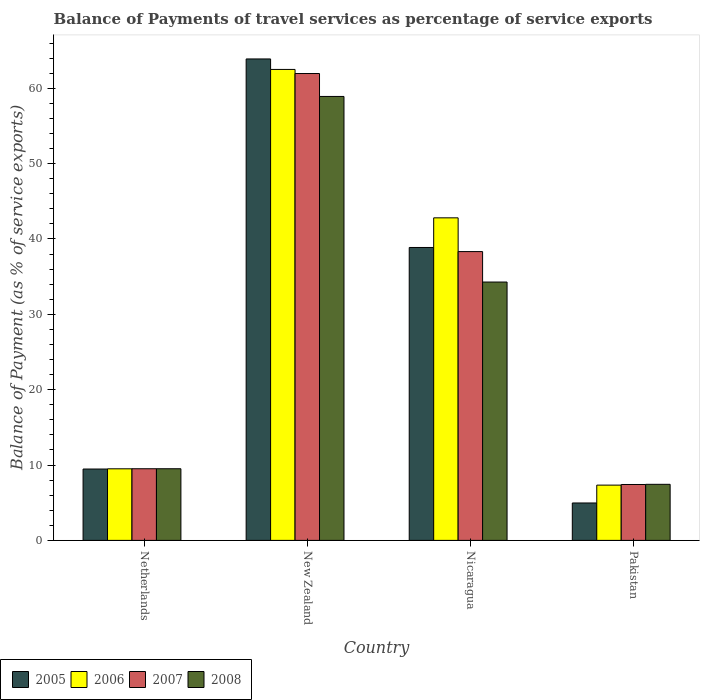How many groups of bars are there?
Your answer should be very brief. 4. What is the label of the 2nd group of bars from the left?
Offer a very short reply. New Zealand. What is the balance of payments of travel services in 2006 in New Zealand?
Your answer should be very brief. 62.5. Across all countries, what is the maximum balance of payments of travel services in 2008?
Your response must be concise. 58.91. Across all countries, what is the minimum balance of payments of travel services in 2005?
Your answer should be compact. 4.97. In which country was the balance of payments of travel services in 2006 maximum?
Your response must be concise. New Zealand. What is the total balance of payments of travel services in 2006 in the graph?
Your answer should be very brief. 122.14. What is the difference between the balance of payments of travel services in 2005 in New Zealand and that in Pakistan?
Provide a short and direct response. 58.93. What is the difference between the balance of payments of travel services in 2006 in Netherlands and the balance of payments of travel services in 2007 in Nicaragua?
Make the answer very short. -28.83. What is the average balance of payments of travel services in 2006 per country?
Keep it short and to the point. 30.54. What is the difference between the balance of payments of travel services of/in 2006 and balance of payments of travel services of/in 2008 in New Zealand?
Make the answer very short. 3.59. What is the ratio of the balance of payments of travel services in 2008 in Nicaragua to that in Pakistan?
Offer a very short reply. 4.61. What is the difference between the highest and the second highest balance of payments of travel services in 2008?
Offer a terse response. -49.41. What is the difference between the highest and the lowest balance of payments of travel services in 2007?
Keep it short and to the point. 54.54. What does the 4th bar from the right in New Zealand represents?
Your response must be concise. 2005. How many countries are there in the graph?
Provide a succinct answer. 4. Does the graph contain any zero values?
Make the answer very short. No. Does the graph contain grids?
Provide a short and direct response. No. How many legend labels are there?
Make the answer very short. 4. What is the title of the graph?
Your answer should be compact. Balance of Payments of travel services as percentage of service exports. Does "1983" appear as one of the legend labels in the graph?
Make the answer very short. No. What is the label or title of the X-axis?
Your response must be concise. Country. What is the label or title of the Y-axis?
Offer a very short reply. Balance of Payment (as % of service exports). What is the Balance of Payment (as % of service exports) in 2005 in Netherlands?
Your response must be concise. 9.47. What is the Balance of Payment (as % of service exports) in 2006 in Netherlands?
Offer a terse response. 9.5. What is the Balance of Payment (as % of service exports) in 2007 in Netherlands?
Offer a very short reply. 9.51. What is the Balance of Payment (as % of service exports) of 2008 in Netherlands?
Your answer should be compact. 9.51. What is the Balance of Payment (as % of service exports) in 2005 in New Zealand?
Make the answer very short. 63.89. What is the Balance of Payment (as % of service exports) of 2006 in New Zealand?
Make the answer very short. 62.5. What is the Balance of Payment (as % of service exports) in 2007 in New Zealand?
Offer a terse response. 61.96. What is the Balance of Payment (as % of service exports) in 2008 in New Zealand?
Offer a very short reply. 58.91. What is the Balance of Payment (as % of service exports) of 2005 in Nicaragua?
Offer a terse response. 38.87. What is the Balance of Payment (as % of service exports) in 2006 in Nicaragua?
Provide a succinct answer. 42.81. What is the Balance of Payment (as % of service exports) in 2007 in Nicaragua?
Your answer should be compact. 38.33. What is the Balance of Payment (as % of service exports) of 2008 in Nicaragua?
Your response must be concise. 34.29. What is the Balance of Payment (as % of service exports) in 2005 in Pakistan?
Offer a very short reply. 4.97. What is the Balance of Payment (as % of service exports) of 2006 in Pakistan?
Ensure brevity in your answer.  7.34. What is the Balance of Payment (as % of service exports) of 2007 in Pakistan?
Offer a very short reply. 7.42. What is the Balance of Payment (as % of service exports) of 2008 in Pakistan?
Keep it short and to the point. 7.44. Across all countries, what is the maximum Balance of Payment (as % of service exports) of 2005?
Ensure brevity in your answer.  63.89. Across all countries, what is the maximum Balance of Payment (as % of service exports) of 2006?
Offer a terse response. 62.5. Across all countries, what is the maximum Balance of Payment (as % of service exports) of 2007?
Your answer should be compact. 61.96. Across all countries, what is the maximum Balance of Payment (as % of service exports) of 2008?
Your response must be concise. 58.91. Across all countries, what is the minimum Balance of Payment (as % of service exports) in 2005?
Your answer should be compact. 4.97. Across all countries, what is the minimum Balance of Payment (as % of service exports) of 2006?
Offer a very short reply. 7.34. Across all countries, what is the minimum Balance of Payment (as % of service exports) in 2007?
Provide a short and direct response. 7.42. Across all countries, what is the minimum Balance of Payment (as % of service exports) in 2008?
Keep it short and to the point. 7.44. What is the total Balance of Payment (as % of service exports) of 2005 in the graph?
Your answer should be very brief. 117.2. What is the total Balance of Payment (as % of service exports) in 2006 in the graph?
Offer a very short reply. 122.14. What is the total Balance of Payment (as % of service exports) in 2007 in the graph?
Offer a very short reply. 117.21. What is the total Balance of Payment (as % of service exports) in 2008 in the graph?
Offer a terse response. 110.15. What is the difference between the Balance of Payment (as % of service exports) in 2005 in Netherlands and that in New Zealand?
Make the answer very short. -54.42. What is the difference between the Balance of Payment (as % of service exports) in 2006 in Netherlands and that in New Zealand?
Your answer should be very brief. -53. What is the difference between the Balance of Payment (as % of service exports) of 2007 in Netherlands and that in New Zealand?
Give a very brief answer. -52.45. What is the difference between the Balance of Payment (as % of service exports) of 2008 in Netherlands and that in New Zealand?
Provide a succinct answer. -49.41. What is the difference between the Balance of Payment (as % of service exports) of 2005 in Netherlands and that in Nicaragua?
Your answer should be very brief. -29.4. What is the difference between the Balance of Payment (as % of service exports) in 2006 in Netherlands and that in Nicaragua?
Ensure brevity in your answer.  -33.31. What is the difference between the Balance of Payment (as % of service exports) of 2007 in Netherlands and that in Nicaragua?
Keep it short and to the point. -28.82. What is the difference between the Balance of Payment (as % of service exports) in 2008 in Netherlands and that in Nicaragua?
Your answer should be compact. -24.78. What is the difference between the Balance of Payment (as % of service exports) in 2005 in Netherlands and that in Pakistan?
Offer a very short reply. 4.51. What is the difference between the Balance of Payment (as % of service exports) of 2006 in Netherlands and that in Pakistan?
Your answer should be very brief. 2.16. What is the difference between the Balance of Payment (as % of service exports) in 2007 in Netherlands and that in Pakistan?
Make the answer very short. 2.09. What is the difference between the Balance of Payment (as % of service exports) in 2008 in Netherlands and that in Pakistan?
Your answer should be compact. 2.07. What is the difference between the Balance of Payment (as % of service exports) of 2005 in New Zealand and that in Nicaragua?
Your response must be concise. 25.02. What is the difference between the Balance of Payment (as % of service exports) of 2006 in New Zealand and that in Nicaragua?
Give a very brief answer. 19.69. What is the difference between the Balance of Payment (as % of service exports) in 2007 in New Zealand and that in Nicaragua?
Provide a succinct answer. 23.63. What is the difference between the Balance of Payment (as % of service exports) of 2008 in New Zealand and that in Nicaragua?
Your answer should be compact. 24.63. What is the difference between the Balance of Payment (as % of service exports) of 2005 in New Zealand and that in Pakistan?
Your response must be concise. 58.93. What is the difference between the Balance of Payment (as % of service exports) of 2006 in New Zealand and that in Pakistan?
Your answer should be very brief. 55.17. What is the difference between the Balance of Payment (as % of service exports) of 2007 in New Zealand and that in Pakistan?
Provide a succinct answer. 54.54. What is the difference between the Balance of Payment (as % of service exports) in 2008 in New Zealand and that in Pakistan?
Provide a short and direct response. 51.47. What is the difference between the Balance of Payment (as % of service exports) of 2005 in Nicaragua and that in Pakistan?
Your answer should be compact. 33.91. What is the difference between the Balance of Payment (as % of service exports) of 2006 in Nicaragua and that in Pakistan?
Your answer should be compact. 35.47. What is the difference between the Balance of Payment (as % of service exports) in 2007 in Nicaragua and that in Pakistan?
Offer a very short reply. 30.91. What is the difference between the Balance of Payment (as % of service exports) in 2008 in Nicaragua and that in Pakistan?
Your answer should be very brief. 26.85. What is the difference between the Balance of Payment (as % of service exports) of 2005 in Netherlands and the Balance of Payment (as % of service exports) of 2006 in New Zealand?
Offer a very short reply. -53.03. What is the difference between the Balance of Payment (as % of service exports) in 2005 in Netherlands and the Balance of Payment (as % of service exports) in 2007 in New Zealand?
Make the answer very short. -52.49. What is the difference between the Balance of Payment (as % of service exports) in 2005 in Netherlands and the Balance of Payment (as % of service exports) in 2008 in New Zealand?
Keep it short and to the point. -49.44. What is the difference between the Balance of Payment (as % of service exports) of 2006 in Netherlands and the Balance of Payment (as % of service exports) of 2007 in New Zealand?
Offer a very short reply. -52.46. What is the difference between the Balance of Payment (as % of service exports) of 2006 in Netherlands and the Balance of Payment (as % of service exports) of 2008 in New Zealand?
Offer a very short reply. -49.42. What is the difference between the Balance of Payment (as % of service exports) in 2007 in Netherlands and the Balance of Payment (as % of service exports) in 2008 in New Zealand?
Your answer should be very brief. -49.41. What is the difference between the Balance of Payment (as % of service exports) of 2005 in Netherlands and the Balance of Payment (as % of service exports) of 2006 in Nicaragua?
Offer a very short reply. -33.34. What is the difference between the Balance of Payment (as % of service exports) of 2005 in Netherlands and the Balance of Payment (as % of service exports) of 2007 in Nicaragua?
Offer a very short reply. -28.85. What is the difference between the Balance of Payment (as % of service exports) in 2005 in Netherlands and the Balance of Payment (as % of service exports) in 2008 in Nicaragua?
Provide a succinct answer. -24.81. What is the difference between the Balance of Payment (as % of service exports) in 2006 in Netherlands and the Balance of Payment (as % of service exports) in 2007 in Nicaragua?
Your response must be concise. -28.83. What is the difference between the Balance of Payment (as % of service exports) of 2006 in Netherlands and the Balance of Payment (as % of service exports) of 2008 in Nicaragua?
Keep it short and to the point. -24.79. What is the difference between the Balance of Payment (as % of service exports) of 2007 in Netherlands and the Balance of Payment (as % of service exports) of 2008 in Nicaragua?
Offer a terse response. -24.78. What is the difference between the Balance of Payment (as % of service exports) in 2005 in Netherlands and the Balance of Payment (as % of service exports) in 2006 in Pakistan?
Offer a terse response. 2.14. What is the difference between the Balance of Payment (as % of service exports) of 2005 in Netherlands and the Balance of Payment (as % of service exports) of 2007 in Pakistan?
Make the answer very short. 2.05. What is the difference between the Balance of Payment (as % of service exports) of 2005 in Netherlands and the Balance of Payment (as % of service exports) of 2008 in Pakistan?
Ensure brevity in your answer.  2.03. What is the difference between the Balance of Payment (as % of service exports) of 2006 in Netherlands and the Balance of Payment (as % of service exports) of 2007 in Pakistan?
Your answer should be compact. 2.08. What is the difference between the Balance of Payment (as % of service exports) in 2006 in Netherlands and the Balance of Payment (as % of service exports) in 2008 in Pakistan?
Your answer should be very brief. 2.06. What is the difference between the Balance of Payment (as % of service exports) of 2007 in Netherlands and the Balance of Payment (as % of service exports) of 2008 in Pakistan?
Your response must be concise. 2.07. What is the difference between the Balance of Payment (as % of service exports) in 2005 in New Zealand and the Balance of Payment (as % of service exports) in 2006 in Nicaragua?
Offer a very short reply. 21.09. What is the difference between the Balance of Payment (as % of service exports) of 2005 in New Zealand and the Balance of Payment (as % of service exports) of 2007 in Nicaragua?
Offer a terse response. 25.57. What is the difference between the Balance of Payment (as % of service exports) of 2005 in New Zealand and the Balance of Payment (as % of service exports) of 2008 in Nicaragua?
Offer a very short reply. 29.61. What is the difference between the Balance of Payment (as % of service exports) in 2006 in New Zealand and the Balance of Payment (as % of service exports) in 2007 in Nicaragua?
Keep it short and to the point. 24.18. What is the difference between the Balance of Payment (as % of service exports) in 2006 in New Zealand and the Balance of Payment (as % of service exports) in 2008 in Nicaragua?
Your answer should be compact. 28.21. What is the difference between the Balance of Payment (as % of service exports) in 2007 in New Zealand and the Balance of Payment (as % of service exports) in 2008 in Nicaragua?
Provide a succinct answer. 27.67. What is the difference between the Balance of Payment (as % of service exports) of 2005 in New Zealand and the Balance of Payment (as % of service exports) of 2006 in Pakistan?
Keep it short and to the point. 56.56. What is the difference between the Balance of Payment (as % of service exports) in 2005 in New Zealand and the Balance of Payment (as % of service exports) in 2007 in Pakistan?
Make the answer very short. 56.47. What is the difference between the Balance of Payment (as % of service exports) of 2005 in New Zealand and the Balance of Payment (as % of service exports) of 2008 in Pakistan?
Provide a short and direct response. 56.45. What is the difference between the Balance of Payment (as % of service exports) in 2006 in New Zealand and the Balance of Payment (as % of service exports) in 2007 in Pakistan?
Ensure brevity in your answer.  55.08. What is the difference between the Balance of Payment (as % of service exports) of 2006 in New Zealand and the Balance of Payment (as % of service exports) of 2008 in Pakistan?
Your response must be concise. 55.06. What is the difference between the Balance of Payment (as % of service exports) in 2007 in New Zealand and the Balance of Payment (as % of service exports) in 2008 in Pakistan?
Make the answer very short. 54.52. What is the difference between the Balance of Payment (as % of service exports) in 2005 in Nicaragua and the Balance of Payment (as % of service exports) in 2006 in Pakistan?
Make the answer very short. 31.54. What is the difference between the Balance of Payment (as % of service exports) of 2005 in Nicaragua and the Balance of Payment (as % of service exports) of 2007 in Pakistan?
Your answer should be compact. 31.46. What is the difference between the Balance of Payment (as % of service exports) in 2005 in Nicaragua and the Balance of Payment (as % of service exports) in 2008 in Pakistan?
Ensure brevity in your answer.  31.43. What is the difference between the Balance of Payment (as % of service exports) of 2006 in Nicaragua and the Balance of Payment (as % of service exports) of 2007 in Pakistan?
Provide a succinct answer. 35.39. What is the difference between the Balance of Payment (as % of service exports) of 2006 in Nicaragua and the Balance of Payment (as % of service exports) of 2008 in Pakistan?
Your response must be concise. 35.37. What is the difference between the Balance of Payment (as % of service exports) in 2007 in Nicaragua and the Balance of Payment (as % of service exports) in 2008 in Pakistan?
Your answer should be very brief. 30.89. What is the average Balance of Payment (as % of service exports) in 2005 per country?
Your answer should be compact. 29.3. What is the average Balance of Payment (as % of service exports) of 2006 per country?
Provide a short and direct response. 30.54. What is the average Balance of Payment (as % of service exports) in 2007 per country?
Offer a very short reply. 29.3. What is the average Balance of Payment (as % of service exports) of 2008 per country?
Your response must be concise. 27.54. What is the difference between the Balance of Payment (as % of service exports) of 2005 and Balance of Payment (as % of service exports) of 2006 in Netherlands?
Your answer should be compact. -0.03. What is the difference between the Balance of Payment (as % of service exports) of 2005 and Balance of Payment (as % of service exports) of 2007 in Netherlands?
Your answer should be very brief. -0.04. What is the difference between the Balance of Payment (as % of service exports) of 2005 and Balance of Payment (as % of service exports) of 2008 in Netherlands?
Offer a terse response. -0.04. What is the difference between the Balance of Payment (as % of service exports) in 2006 and Balance of Payment (as % of service exports) in 2007 in Netherlands?
Keep it short and to the point. -0.01. What is the difference between the Balance of Payment (as % of service exports) of 2006 and Balance of Payment (as % of service exports) of 2008 in Netherlands?
Give a very brief answer. -0.01. What is the difference between the Balance of Payment (as % of service exports) of 2007 and Balance of Payment (as % of service exports) of 2008 in Netherlands?
Provide a short and direct response. -0. What is the difference between the Balance of Payment (as % of service exports) of 2005 and Balance of Payment (as % of service exports) of 2006 in New Zealand?
Give a very brief answer. 1.39. What is the difference between the Balance of Payment (as % of service exports) of 2005 and Balance of Payment (as % of service exports) of 2007 in New Zealand?
Provide a short and direct response. 1.93. What is the difference between the Balance of Payment (as % of service exports) in 2005 and Balance of Payment (as % of service exports) in 2008 in New Zealand?
Your answer should be very brief. 4.98. What is the difference between the Balance of Payment (as % of service exports) of 2006 and Balance of Payment (as % of service exports) of 2007 in New Zealand?
Offer a terse response. 0.54. What is the difference between the Balance of Payment (as % of service exports) in 2006 and Balance of Payment (as % of service exports) in 2008 in New Zealand?
Provide a short and direct response. 3.59. What is the difference between the Balance of Payment (as % of service exports) in 2007 and Balance of Payment (as % of service exports) in 2008 in New Zealand?
Offer a terse response. 3.04. What is the difference between the Balance of Payment (as % of service exports) in 2005 and Balance of Payment (as % of service exports) in 2006 in Nicaragua?
Offer a terse response. -3.93. What is the difference between the Balance of Payment (as % of service exports) of 2005 and Balance of Payment (as % of service exports) of 2007 in Nicaragua?
Provide a short and direct response. 0.55. What is the difference between the Balance of Payment (as % of service exports) in 2005 and Balance of Payment (as % of service exports) in 2008 in Nicaragua?
Provide a succinct answer. 4.59. What is the difference between the Balance of Payment (as % of service exports) of 2006 and Balance of Payment (as % of service exports) of 2007 in Nicaragua?
Offer a very short reply. 4.48. What is the difference between the Balance of Payment (as % of service exports) in 2006 and Balance of Payment (as % of service exports) in 2008 in Nicaragua?
Your response must be concise. 8.52. What is the difference between the Balance of Payment (as % of service exports) of 2007 and Balance of Payment (as % of service exports) of 2008 in Nicaragua?
Your answer should be compact. 4.04. What is the difference between the Balance of Payment (as % of service exports) in 2005 and Balance of Payment (as % of service exports) in 2006 in Pakistan?
Keep it short and to the point. -2.37. What is the difference between the Balance of Payment (as % of service exports) in 2005 and Balance of Payment (as % of service exports) in 2007 in Pakistan?
Your answer should be very brief. -2.45. What is the difference between the Balance of Payment (as % of service exports) of 2005 and Balance of Payment (as % of service exports) of 2008 in Pakistan?
Your answer should be compact. -2.47. What is the difference between the Balance of Payment (as % of service exports) in 2006 and Balance of Payment (as % of service exports) in 2007 in Pakistan?
Ensure brevity in your answer.  -0.08. What is the difference between the Balance of Payment (as % of service exports) in 2006 and Balance of Payment (as % of service exports) in 2008 in Pakistan?
Provide a short and direct response. -0.1. What is the difference between the Balance of Payment (as % of service exports) of 2007 and Balance of Payment (as % of service exports) of 2008 in Pakistan?
Ensure brevity in your answer.  -0.02. What is the ratio of the Balance of Payment (as % of service exports) in 2005 in Netherlands to that in New Zealand?
Your answer should be very brief. 0.15. What is the ratio of the Balance of Payment (as % of service exports) of 2006 in Netherlands to that in New Zealand?
Provide a short and direct response. 0.15. What is the ratio of the Balance of Payment (as % of service exports) of 2007 in Netherlands to that in New Zealand?
Give a very brief answer. 0.15. What is the ratio of the Balance of Payment (as % of service exports) of 2008 in Netherlands to that in New Zealand?
Give a very brief answer. 0.16. What is the ratio of the Balance of Payment (as % of service exports) of 2005 in Netherlands to that in Nicaragua?
Your answer should be compact. 0.24. What is the ratio of the Balance of Payment (as % of service exports) of 2006 in Netherlands to that in Nicaragua?
Give a very brief answer. 0.22. What is the ratio of the Balance of Payment (as % of service exports) of 2007 in Netherlands to that in Nicaragua?
Provide a short and direct response. 0.25. What is the ratio of the Balance of Payment (as % of service exports) in 2008 in Netherlands to that in Nicaragua?
Your answer should be compact. 0.28. What is the ratio of the Balance of Payment (as % of service exports) in 2005 in Netherlands to that in Pakistan?
Your response must be concise. 1.91. What is the ratio of the Balance of Payment (as % of service exports) in 2006 in Netherlands to that in Pakistan?
Make the answer very short. 1.29. What is the ratio of the Balance of Payment (as % of service exports) of 2007 in Netherlands to that in Pakistan?
Your answer should be compact. 1.28. What is the ratio of the Balance of Payment (as % of service exports) of 2008 in Netherlands to that in Pakistan?
Your response must be concise. 1.28. What is the ratio of the Balance of Payment (as % of service exports) in 2005 in New Zealand to that in Nicaragua?
Keep it short and to the point. 1.64. What is the ratio of the Balance of Payment (as % of service exports) of 2006 in New Zealand to that in Nicaragua?
Provide a succinct answer. 1.46. What is the ratio of the Balance of Payment (as % of service exports) in 2007 in New Zealand to that in Nicaragua?
Your answer should be very brief. 1.62. What is the ratio of the Balance of Payment (as % of service exports) in 2008 in New Zealand to that in Nicaragua?
Keep it short and to the point. 1.72. What is the ratio of the Balance of Payment (as % of service exports) of 2005 in New Zealand to that in Pakistan?
Provide a short and direct response. 12.87. What is the ratio of the Balance of Payment (as % of service exports) in 2006 in New Zealand to that in Pakistan?
Your answer should be compact. 8.52. What is the ratio of the Balance of Payment (as % of service exports) of 2007 in New Zealand to that in Pakistan?
Offer a very short reply. 8.35. What is the ratio of the Balance of Payment (as % of service exports) of 2008 in New Zealand to that in Pakistan?
Make the answer very short. 7.92. What is the ratio of the Balance of Payment (as % of service exports) of 2005 in Nicaragua to that in Pakistan?
Your response must be concise. 7.83. What is the ratio of the Balance of Payment (as % of service exports) in 2006 in Nicaragua to that in Pakistan?
Make the answer very short. 5.84. What is the ratio of the Balance of Payment (as % of service exports) of 2007 in Nicaragua to that in Pakistan?
Offer a very short reply. 5.17. What is the ratio of the Balance of Payment (as % of service exports) of 2008 in Nicaragua to that in Pakistan?
Give a very brief answer. 4.61. What is the difference between the highest and the second highest Balance of Payment (as % of service exports) in 2005?
Your answer should be compact. 25.02. What is the difference between the highest and the second highest Balance of Payment (as % of service exports) of 2006?
Your answer should be very brief. 19.69. What is the difference between the highest and the second highest Balance of Payment (as % of service exports) of 2007?
Provide a short and direct response. 23.63. What is the difference between the highest and the second highest Balance of Payment (as % of service exports) of 2008?
Offer a very short reply. 24.63. What is the difference between the highest and the lowest Balance of Payment (as % of service exports) in 2005?
Provide a short and direct response. 58.93. What is the difference between the highest and the lowest Balance of Payment (as % of service exports) in 2006?
Provide a succinct answer. 55.17. What is the difference between the highest and the lowest Balance of Payment (as % of service exports) of 2007?
Provide a succinct answer. 54.54. What is the difference between the highest and the lowest Balance of Payment (as % of service exports) in 2008?
Offer a very short reply. 51.47. 